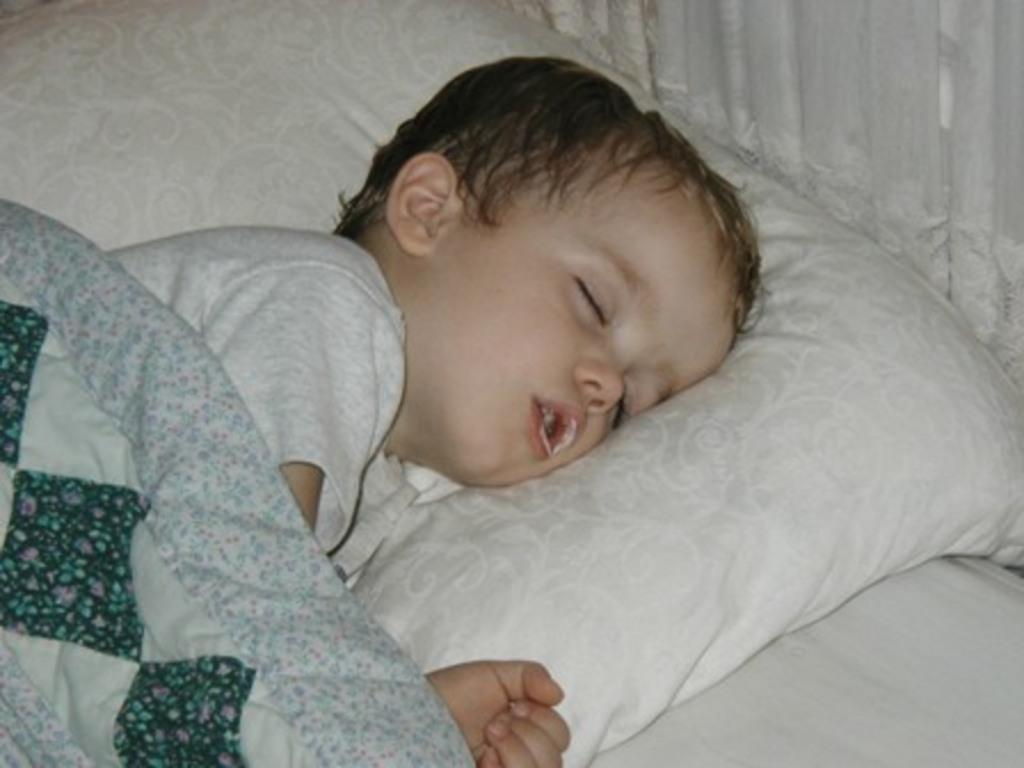What is the kid doing in the image? The kid is laying on the bed in the image. What object can be seen near the kid? There is a pillow in the image. What type of flame can be seen on the chair in the image? There is no chair or flame present in the image. How many beads are on the kid's necklace in the image? There is no necklace or beads visible in the image. 